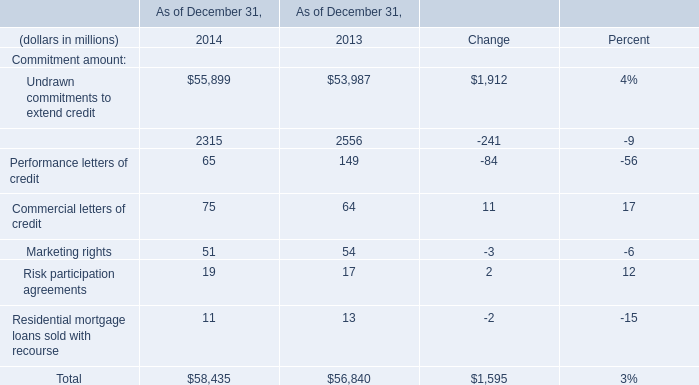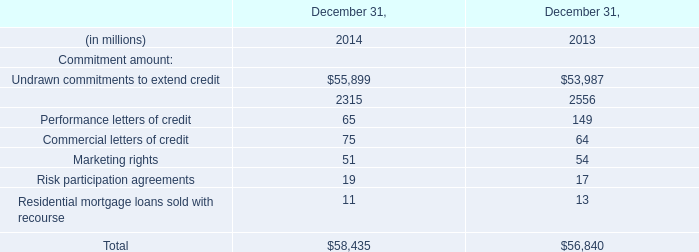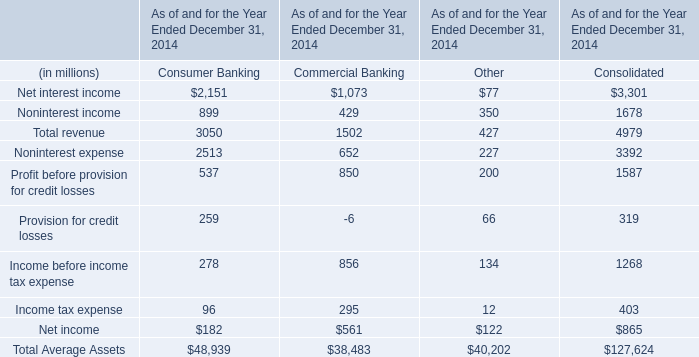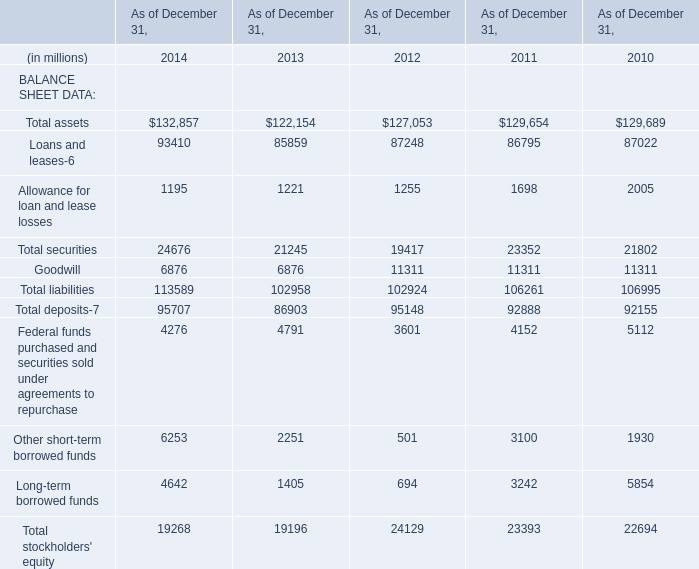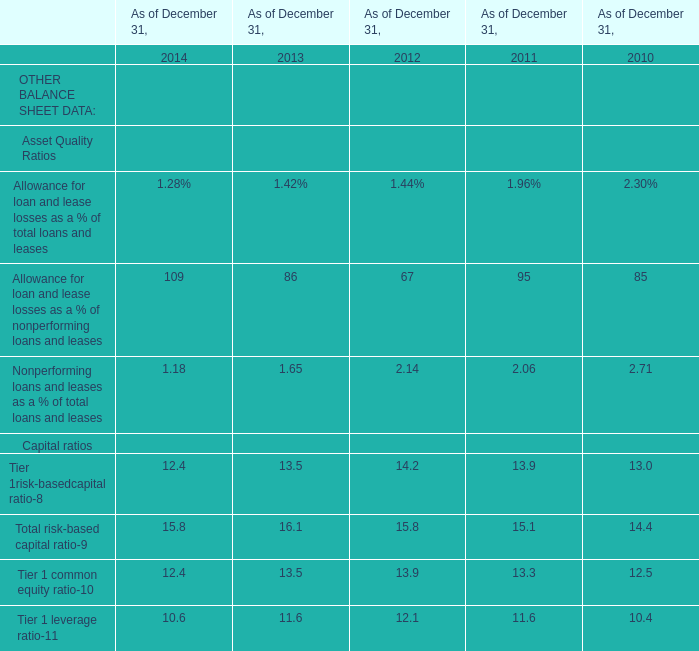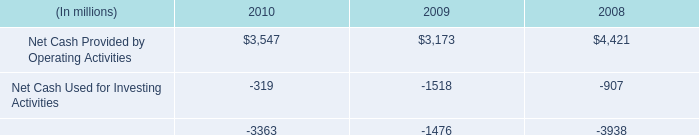what was the percentage change in capital expenditures for property , plant and equipment from 2008 to 2009? 
Computations: ((852 - 926) / 926)
Answer: -0.07991. 